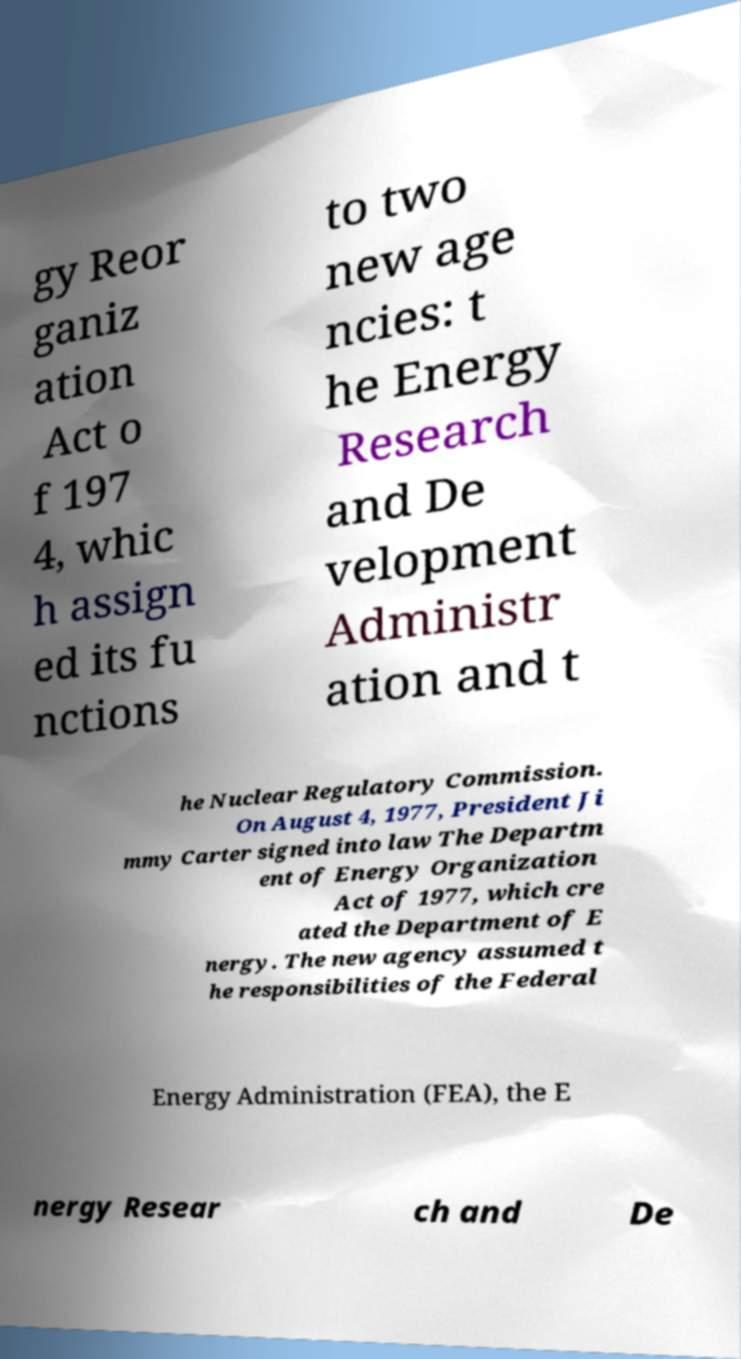Please read and relay the text visible in this image. What does it say? gy Reor ganiz ation Act o f 197 4, whic h assign ed its fu nctions to two new age ncies: t he Energy Research and De velopment Administr ation and t he Nuclear Regulatory Commission. On August 4, 1977, President Ji mmy Carter signed into law The Departm ent of Energy Organization Act of 1977, which cre ated the Department of E nergy. The new agency assumed t he responsibilities of the Federal Energy Administration (FEA), the E nergy Resear ch and De 